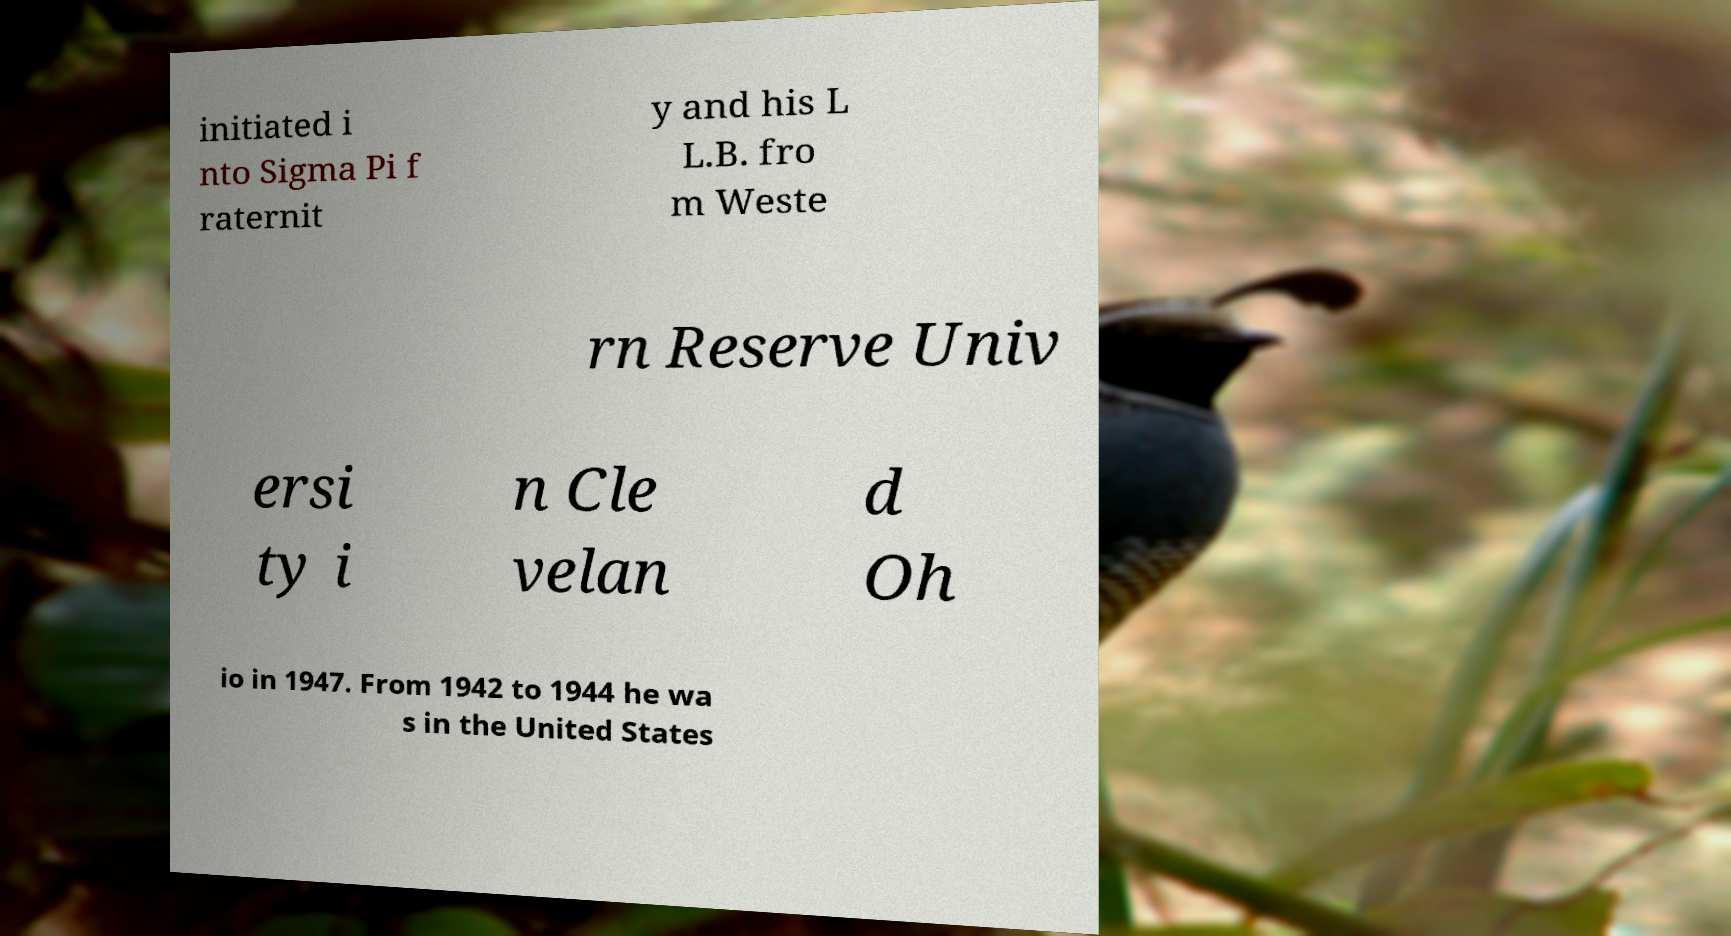I need the written content from this picture converted into text. Can you do that? initiated i nto Sigma Pi f raternit y and his L L.B. fro m Weste rn Reserve Univ ersi ty i n Cle velan d Oh io in 1947. From 1942 to 1944 he wa s in the United States 